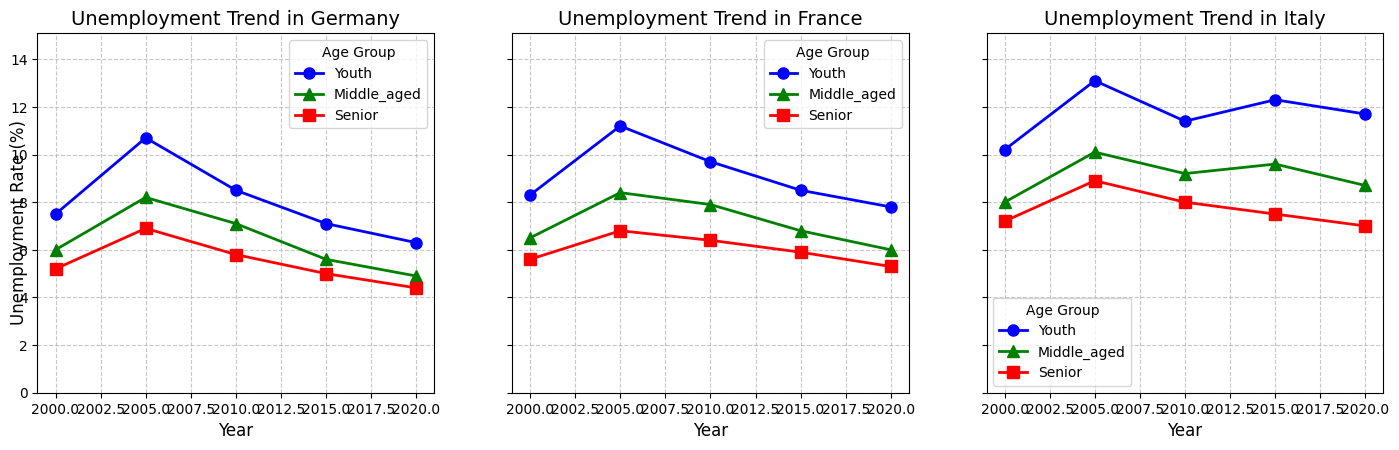Which age group had the highest unemployment rate in Germany in 2005? Upon examining the plot for Germany, look at the data points for each age group in 2005. The Youth group has an unemployment rate of 10.7%, which is higher than both Middle-aged (8.2%) and Senior (6.9%) groups.
Answer: Youth How did the unemployment rate for middle-aged people in France change from 2000 to 2020? Observe the trend line for the Middle-aged group in the France subplot. The unemployment rate decreased from 6.5% in 2000 to 6.0% in 2020, showing an overall decrease.
Answer: Decreased Which country had the largest difference between Youth and Senior unemployment rates in 2005? Compare the differences in unemployment rates between Youth and Senior groups for each country in 2005. For Germany, the difference is 10.7 - 6.9 = 3.8%. For France, it is 11.2 - 6.8 = 4.4%. For Italy, it is 13.1 - 8.9 = 4.2%. France has the largest difference.
Answer: France Did the unemployment rate for senior people in Italy ever fall below 7% during the observed period? Check the trend line for the Senior group in the Italy subplot. The rate is never below 7% at any point from 2000 to 2020.
Answer: No What year did Germany have the lowest unemployment rate across all age groups? Look at the Germany subplot and identify the year with the lowest data points across all age groups. In 2020, Youth (6.3%), Middle-aged (4.9%), and Senior (4.4%) all show lower rates compared to other years.
Answer: 2020 Which country experienced the most consistent decrease in unemployment rate for middle-aged individuals from 2000 to 2020? Check the trend lines for the Middle-aged group for all countries. Germany shows a consistent decrease from 6.0% in 2000 to 4.9% in 2020.
Answer: Germany How do the unemployment rates for Youth in France in 2010 compare to those in Italy in 2010? Compare the data points for Youth in the France and Italy subplots for the year 2010. France has a rate of 9.7%, while Italy has 11.4%.
Answer: France is lower 